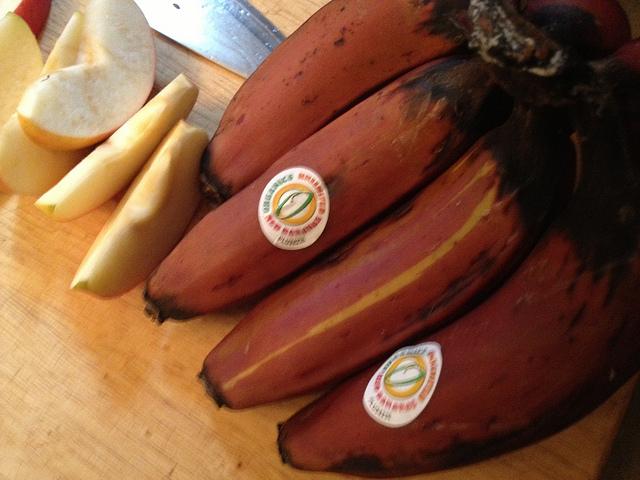Are the sliced fruits the same kind as the whole ones?
Answer briefly. No. Is the banana green?
Keep it brief. No. The fruit that is not sliced are called what?
Short answer required. Bananas. Are the bananas ripe?
Keep it brief. Yes. 